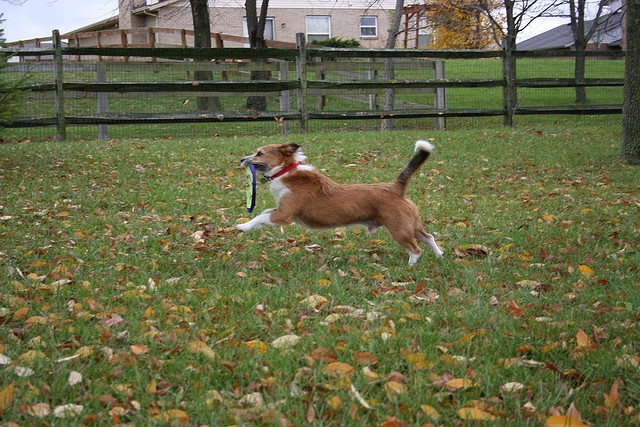Describe the objects in this image and their specific colors. I can see dog in lavender, brown, gray, and maroon tones and frisbee in lavender, black, lightgreen, olive, and gray tones in this image. 